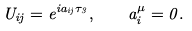<formula> <loc_0><loc_0><loc_500><loc_500>U _ { i j } = e ^ { i a _ { i j } \tau _ { 3 } } , \quad a ^ { \mu } _ { i } = 0 .</formula> 